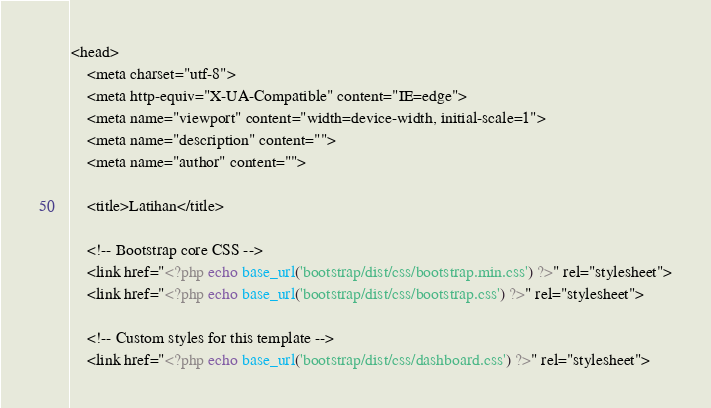<code> <loc_0><loc_0><loc_500><loc_500><_PHP_><head>
    <meta charset="utf-8">
    <meta http-equiv="X-UA-Compatible" content="IE=edge">
    <meta name="viewport" content="width=device-width, initial-scale=1">
    <meta name="description" content="">
    <meta name="author" content="">

    <title>Latihan</title>

    <!-- Bootstrap core CSS -->
    <link href="<?php echo base_url('bootstrap/dist/css/bootstrap.min.css') ?>" rel="stylesheet">
    <link href="<?php echo base_url('bootstrap/dist/css/bootstrap.css') ?>" rel="stylesheet">

    <!-- Custom styles for this template -->
    <link href="<?php echo base_url('bootstrap/dist/css/dashboard.css') ?>" rel="stylesheet"></code> 